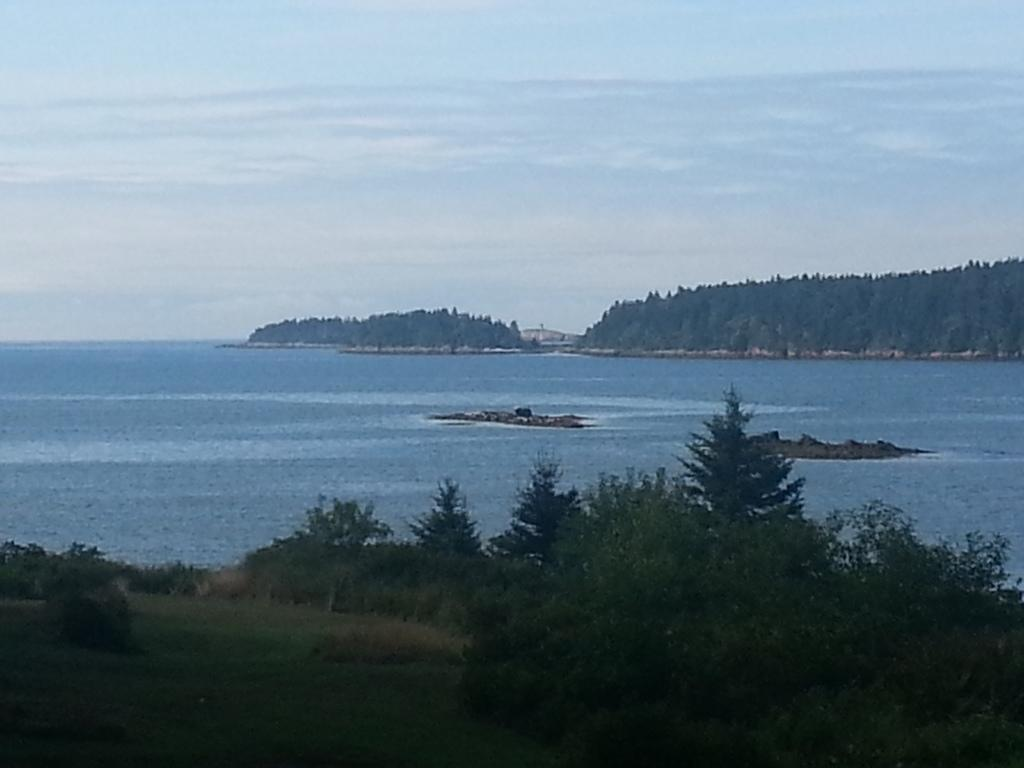What type of vegetation can be seen in the image? There are trees in the image. What natural element is visible in the image? There is water visible in the image. Can you describe the background of the image? There are trees and the sky visible in the background of the image. What can be seen in the sky in the image? Clouds are present in the sky. What type of noise can be heard coming from the station in the image? There is no station present in the image, so it is not possible to determine what noise might be heard. 